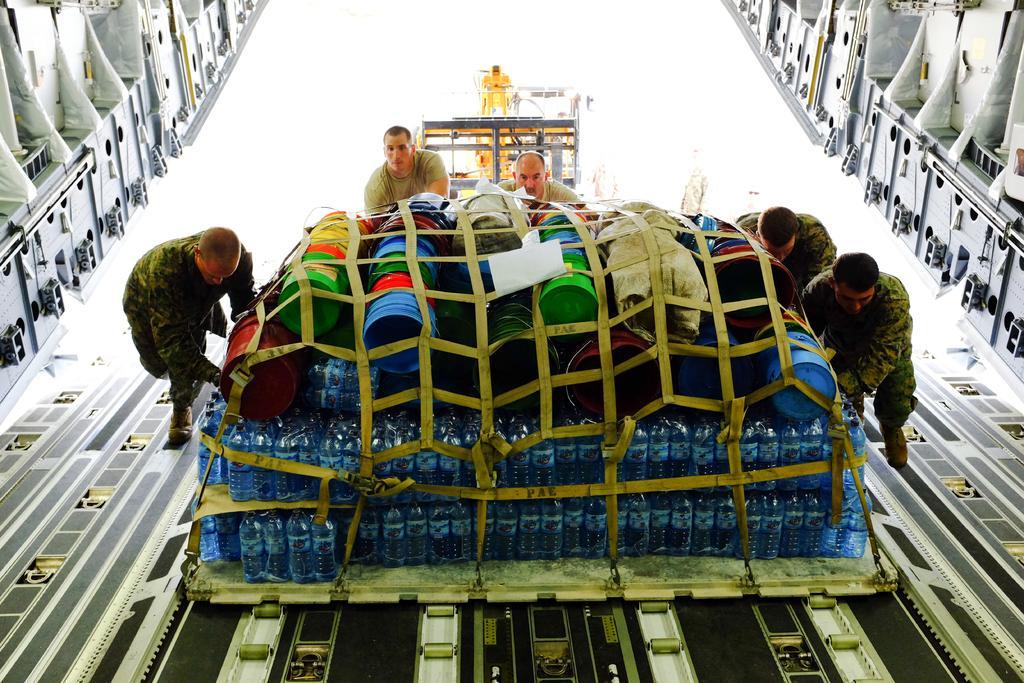How would you summarize this image in a sentence or two? In this image we can see the group of bottles and mats and there are few persons pushing those into an aircraft. Behind the a person we can see a vehicle and few persons. 